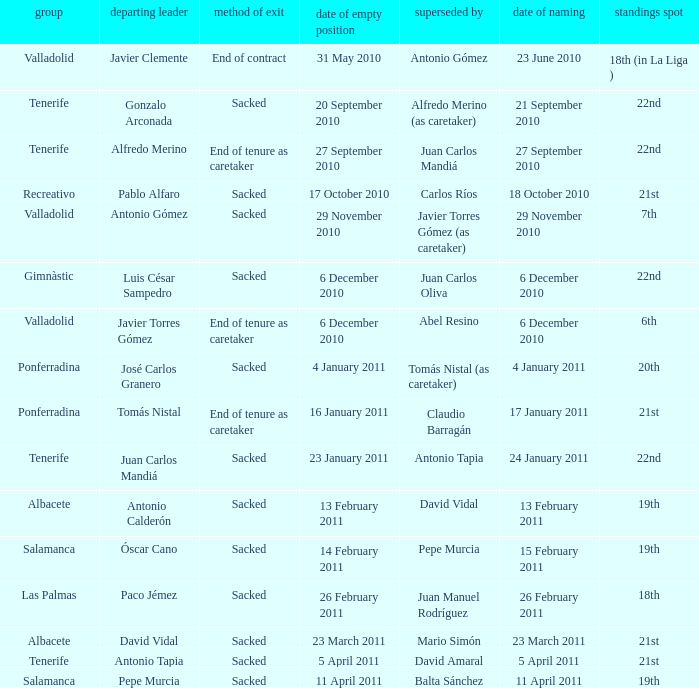What is the position for outgoing manager alfredo merino 22nd. 